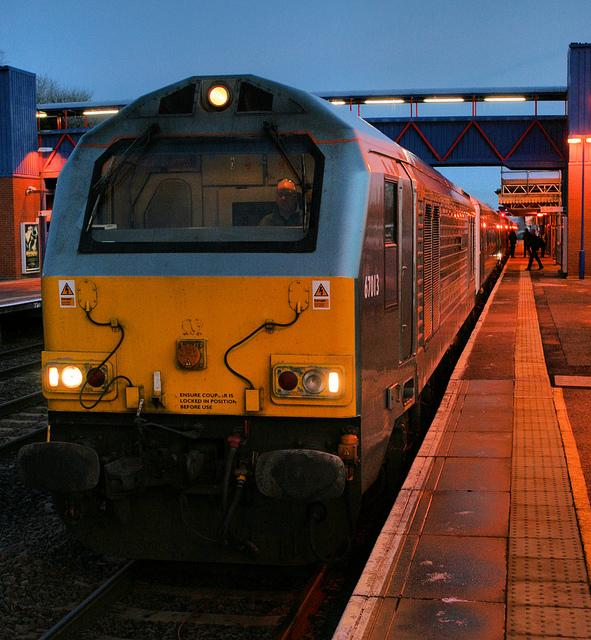What is the man inside the front of the training doing?

Choices:
A) driving
B) loading
C) boarding
D) policing driving 